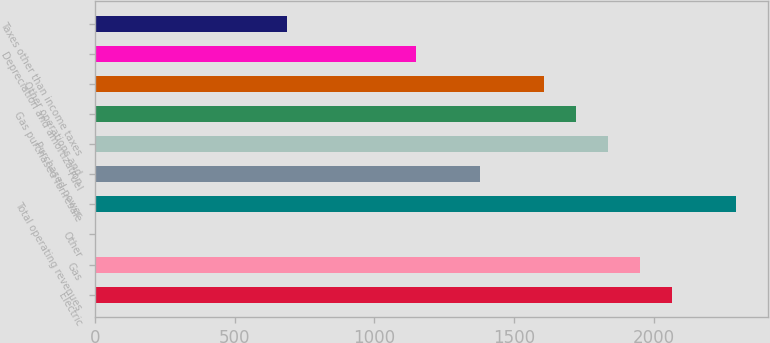<chart> <loc_0><loc_0><loc_500><loc_500><bar_chart><fcel>Electric<fcel>Gas<fcel>Other<fcel>Total operating revenues<fcel>Fuel<fcel>Purchased power<fcel>Gas purchased for resale<fcel>Other operations and<fcel>Depreciation and amortization<fcel>Taxes other than income taxes<nl><fcel>2063.8<fcel>1949.2<fcel>1<fcel>2293<fcel>1376.2<fcel>1834.6<fcel>1720<fcel>1605.4<fcel>1147<fcel>688.6<nl></chart> 